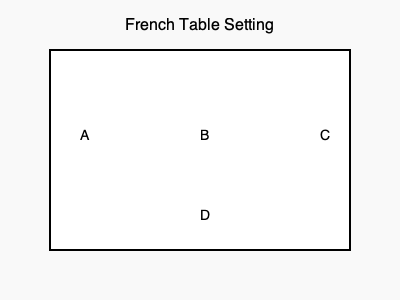In a traditional French meal structure, arrange the following courses in the correct order by placing them in the appropriate positions (A, B, C, D) on the table diagram: Plat principal, Entrée, Fromage, Dessert. To arrange the French cuisine dishes according to a traditional meal structure, follow these steps:

1. Understand the traditional French meal structure:
   - Entrée (starter or appetizer)
   - Plat principal (main course)
   - Fromage (cheese course)
   - Dessert

2. Assign the courses to the positions on the table:
   A. Entrée: This is the first course, so it should be placed at position A.
   B. Plat principal: As the main course, it follows the entrée and belongs in position B.
   C. Fromage: The cheese course comes after the main dish, so it goes in position C.
   D. Dessert: The final course of the meal, dessert, is placed in position D.

3. The correct arrangement from left to right and top to bottom:
   A: Entrée
   B: Plat principal
   C: Fromage
   D: Dessert

This arrangement reflects the traditional sequence of courses in a formal French meal, allowing diners to experience the progression of flavors and textures that characterize French cuisine.
Answer: A: Entrée, B: Plat principal, C: Fromage, D: Dessert 